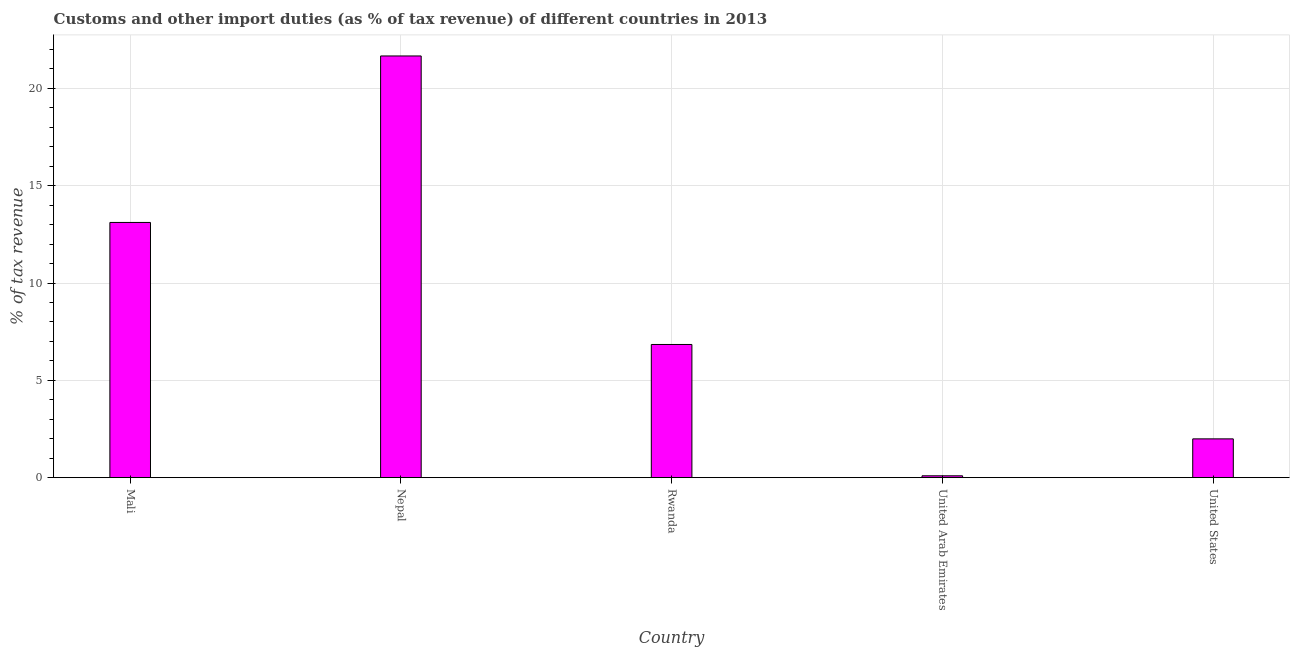Does the graph contain any zero values?
Provide a short and direct response. No. What is the title of the graph?
Give a very brief answer. Customs and other import duties (as % of tax revenue) of different countries in 2013. What is the label or title of the Y-axis?
Your answer should be very brief. % of tax revenue. What is the customs and other import duties in United States?
Provide a succinct answer. 1.99. Across all countries, what is the maximum customs and other import duties?
Offer a terse response. 21.67. Across all countries, what is the minimum customs and other import duties?
Your answer should be compact. 0.09. In which country was the customs and other import duties maximum?
Keep it short and to the point. Nepal. In which country was the customs and other import duties minimum?
Your answer should be very brief. United Arab Emirates. What is the sum of the customs and other import duties?
Make the answer very short. 43.71. What is the difference between the customs and other import duties in Nepal and Rwanda?
Your answer should be very brief. 14.82. What is the average customs and other import duties per country?
Ensure brevity in your answer.  8.74. What is the median customs and other import duties?
Offer a terse response. 6.84. In how many countries, is the customs and other import duties greater than 9 %?
Your response must be concise. 2. What is the ratio of the customs and other import duties in Mali to that in Nepal?
Provide a succinct answer. 0.6. Is the customs and other import duties in Mali less than that in Rwanda?
Give a very brief answer. No. Is the difference between the customs and other import duties in Mali and Nepal greater than the difference between any two countries?
Your response must be concise. No. What is the difference between the highest and the second highest customs and other import duties?
Your response must be concise. 8.55. What is the difference between the highest and the lowest customs and other import duties?
Keep it short and to the point. 21.57. In how many countries, is the customs and other import duties greater than the average customs and other import duties taken over all countries?
Ensure brevity in your answer.  2. How many bars are there?
Make the answer very short. 5. Are all the bars in the graph horizontal?
Keep it short and to the point. No. How many countries are there in the graph?
Your response must be concise. 5. What is the % of tax revenue in Mali?
Offer a very short reply. 13.11. What is the % of tax revenue in Nepal?
Make the answer very short. 21.67. What is the % of tax revenue in Rwanda?
Make the answer very short. 6.84. What is the % of tax revenue in United Arab Emirates?
Provide a succinct answer. 0.09. What is the % of tax revenue in United States?
Provide a succinct answer. 1.99. What is the difference between the % of tax revenue in Mali and Nepal?
Provide a short and direct response. -8.55. What is the difference between the % of tax revenue in Mali and Rwanda?
Offer a very short reply. 6.27. What is the difference between the % of tax revenue in Mali and United Arab Emirates?
Give a very brief answer. 13.02. What is the difference between the % of tax revenue in Mali and United States?
Keep it short and to the point. 11.12. What is the difference between the % of tax revenue in Nepal and Rwanda?
Ensure brevity in your answer.  14.82. What is the difference between the % of tax revenue in Nepal and United Arab Emirates?
Your answer should be very brief. 21.57. What is the difference between the % of tax revenue in Nepal and United States?
Give a very brief answer. 19.67. What is the difference between the % of tax revenue in Rwanda and United Arab Emirates?
Make the answer very short. 6.75. What is the difference between the % of tax revenue in Rwanda and United States?
Your response must be concise. 4.85. What is the difference between the % of tax revenue in United Arab Emirates and United States?
Ensure brevity in your answer.  -1.9. What is the ratio of the % of tax revenue in Mali to that in Nepal?
Keep it short and to the point. 0.6. What is the ratio of the % of tax revenue in Mali to that in Rwanda?
Ensure brevity in your answer.  1.92. What is the ratio of the % of tax revenue in Mali to that in United Arab Emirates?
Your response must be concise. 138.6. What is the ratio of the % of tax revenue in Mali to that in United States?
Provide a short and direct response. 6.58. What is the ratio of the % of tax revenue in Nepal to that in Rwanda?
Provide a short and direct response. 3.17. What is the ratio of the % of tax revenue in Nepal to that in United Arab Emirates?
Your response must be concise. 229.03. What is the ratio of the % of tax revenue in Nepal to that in United States?
Keep it short and to the point. 10.87. What is the ratio of the % of tax revenue in Rwanda to that in United Arab Emirates?
Make the answer very short. 72.33. What is the ratio of the % of tax revenue in Rwanda to that in United States?
Keep it short and to the point. 3.43. What is the ratio of the % of tax revenue in United Arab Emirates to that in United States?
Keep it short and to the point. 0.05. 